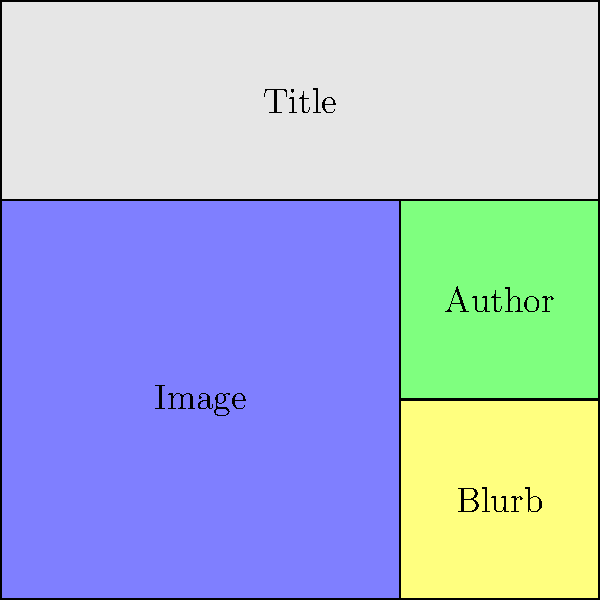As a story analyst evaluating book cover designs, which of the following statements best describes the optimal layout for a book cover based on the grid system shown in the image? To answer this question, let's analyze the grid system and the placement of elements in the book cover design:

1. The grid is divided into a 3x3 layout, providing 9 equal cells for organizing content.

2. The title occupies the entire top row (3 cells), spanning the full width of the cover. This gives prominence to the book's title, which is crucial for attracting potential readers.

3. The image takes up 4 cells (2x2) in the bottom-left corner. This large space allows for an impactful visual representation of the book's content or theme.

4. The author's name is placed in a single cell in the middle-right of the cover. This position balances the layout and gives appropriate visibility to the author.

5. The blurb or additional information occupies a single cell in the bottom-right corner. This placement allows for a brief description or review without overshadowing other elements.

This layout follows several key principles of effective book cover design:

- Hierarchy: The title is given the most prominence, followed by the image, then the author's name, and finally the blurb.
- Balance: The large image is balanced by the smaller text elements on the right side.
- Readability: Each element has a dedicated space, ensuring clarity and ease of reading.
- Flexibility: This grid system allows for easy adaptation to different book genres and styles while maintaining a consistent structure.

Therefore, the optimal layout for a book cover based on this grid system prioritizes the title and image while providing balanced placement for the author's name and additional information.
Answer: Title spans full width, large image in bottom-left, author name in middle-right, blurb in bottom-right. 